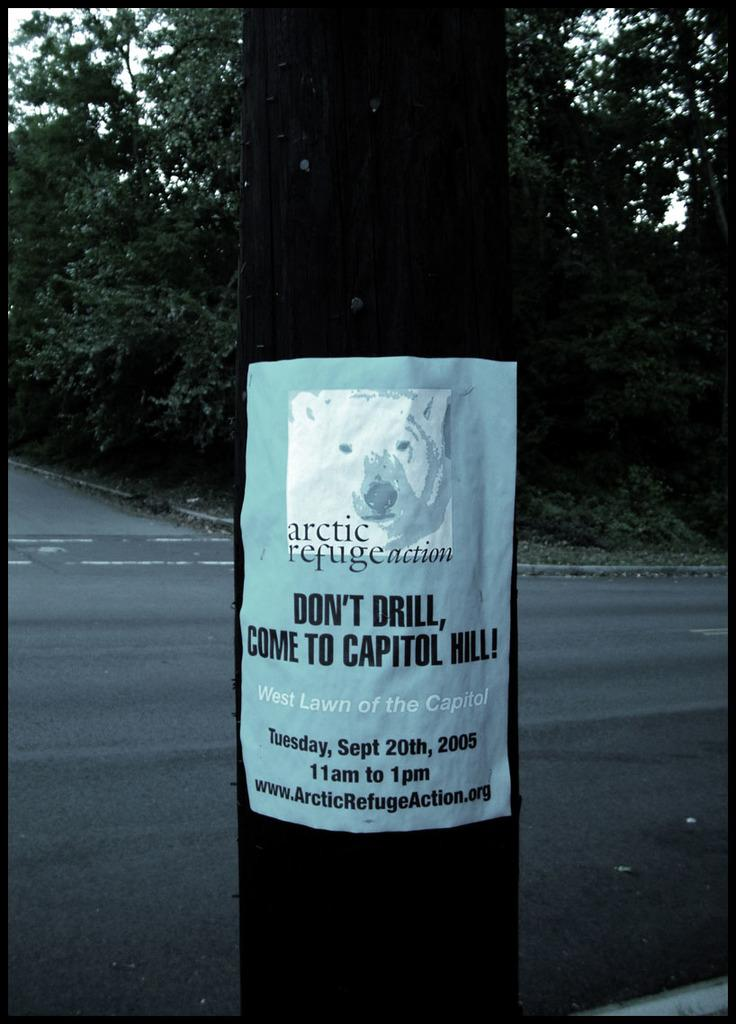What is the main object in the middle of the image? There is a black pole in the middle of the image. What is attached to the pole? There is a paper stick on the pole. What can be seen in the background of the image? There is a road and trees visible in the background. What type of tooth is visible on the paper stick in the image? There is no tooth present on the paper stick or in the image. 